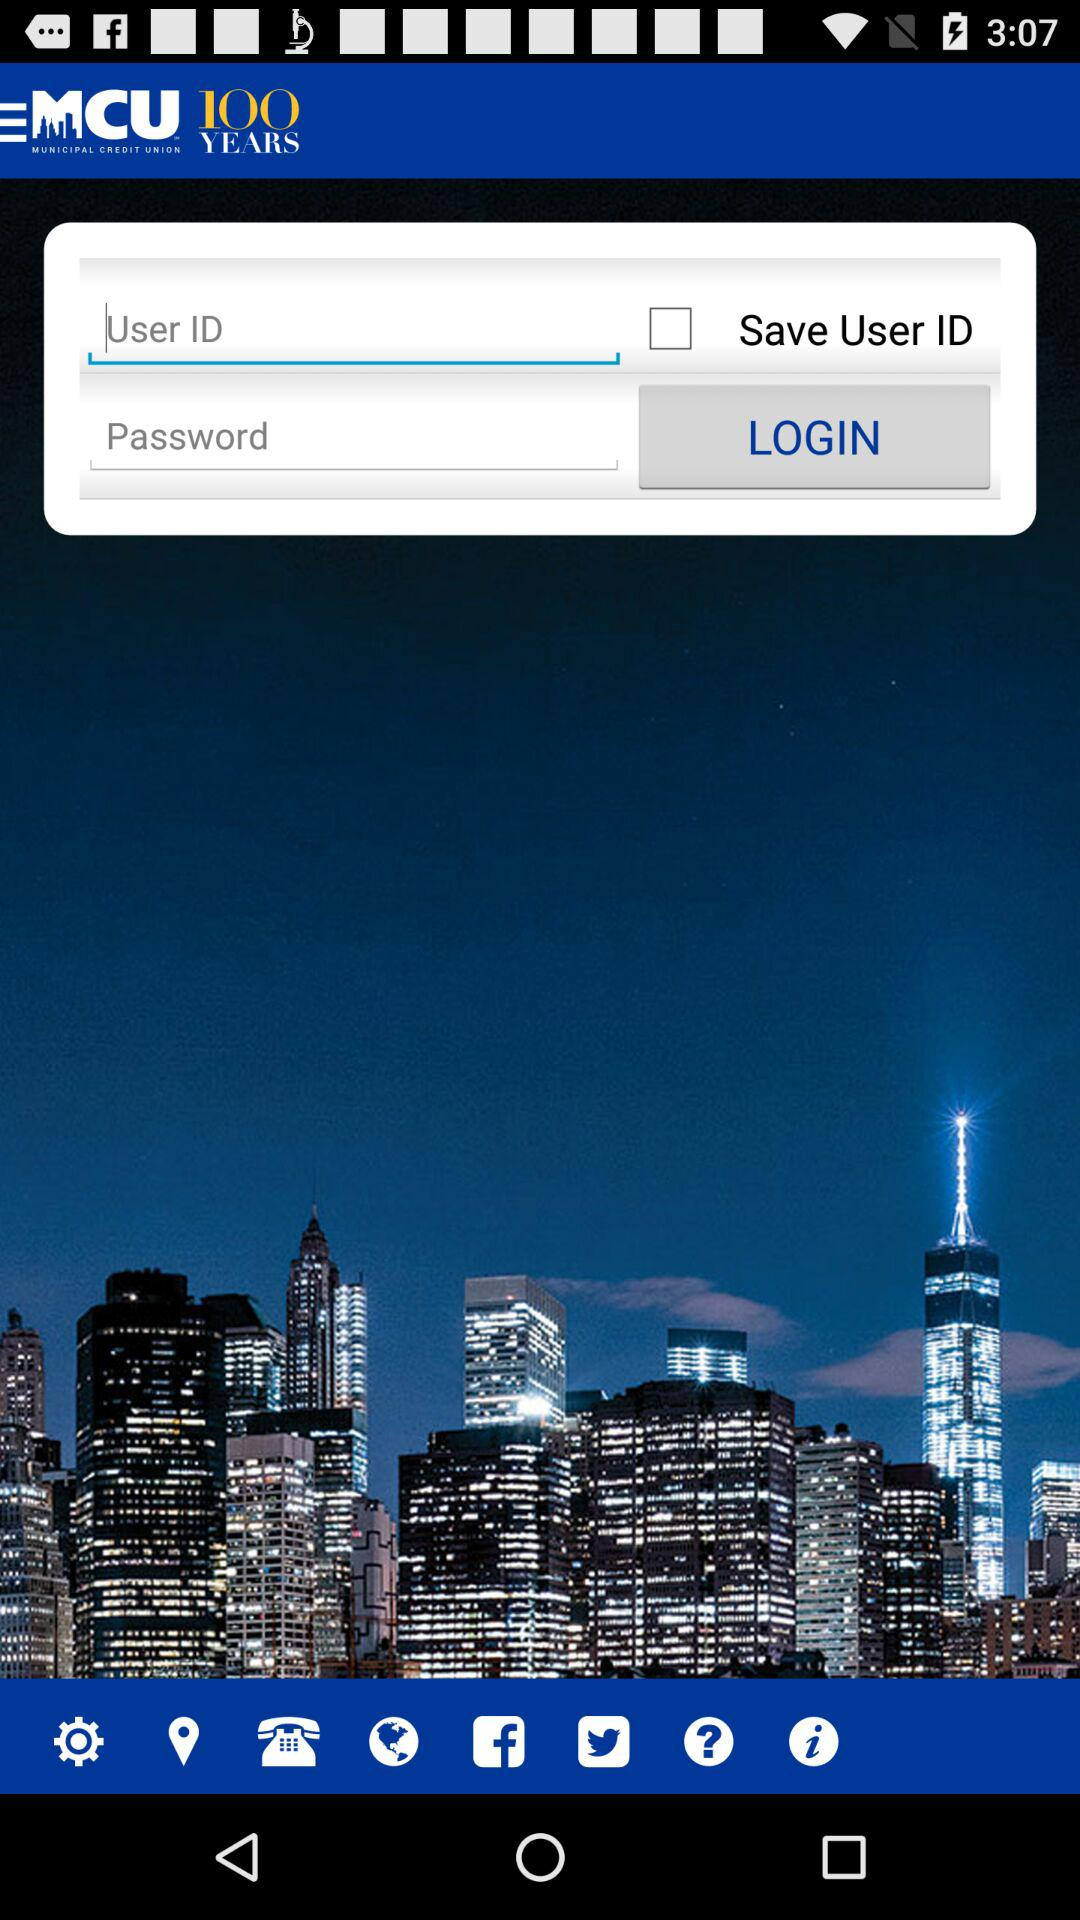What is the status of Save User ID? The status is off. 